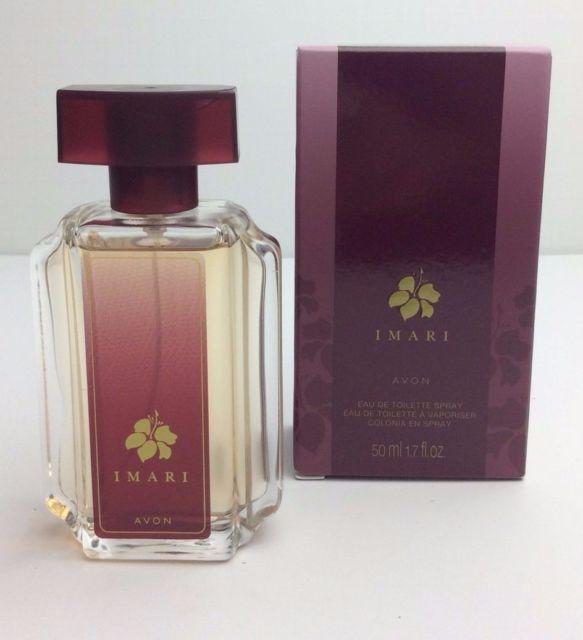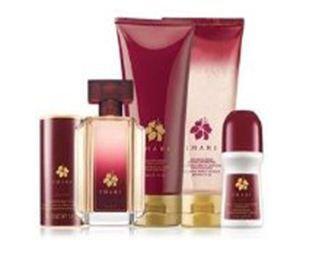The first image is the image on the left, the second image is the image on the right. Given the left and right images, does the statement "A purple perfume bottle is to the left of a black bottle and a red bottle." hold true? Answer yes or no. No. The first image is the image on the left, the second image is the image on the right. Considering the images on both sides, is "The image on the left contains only one bottle of fragrance, and its box." valid? Answer yes or no. Yes. 